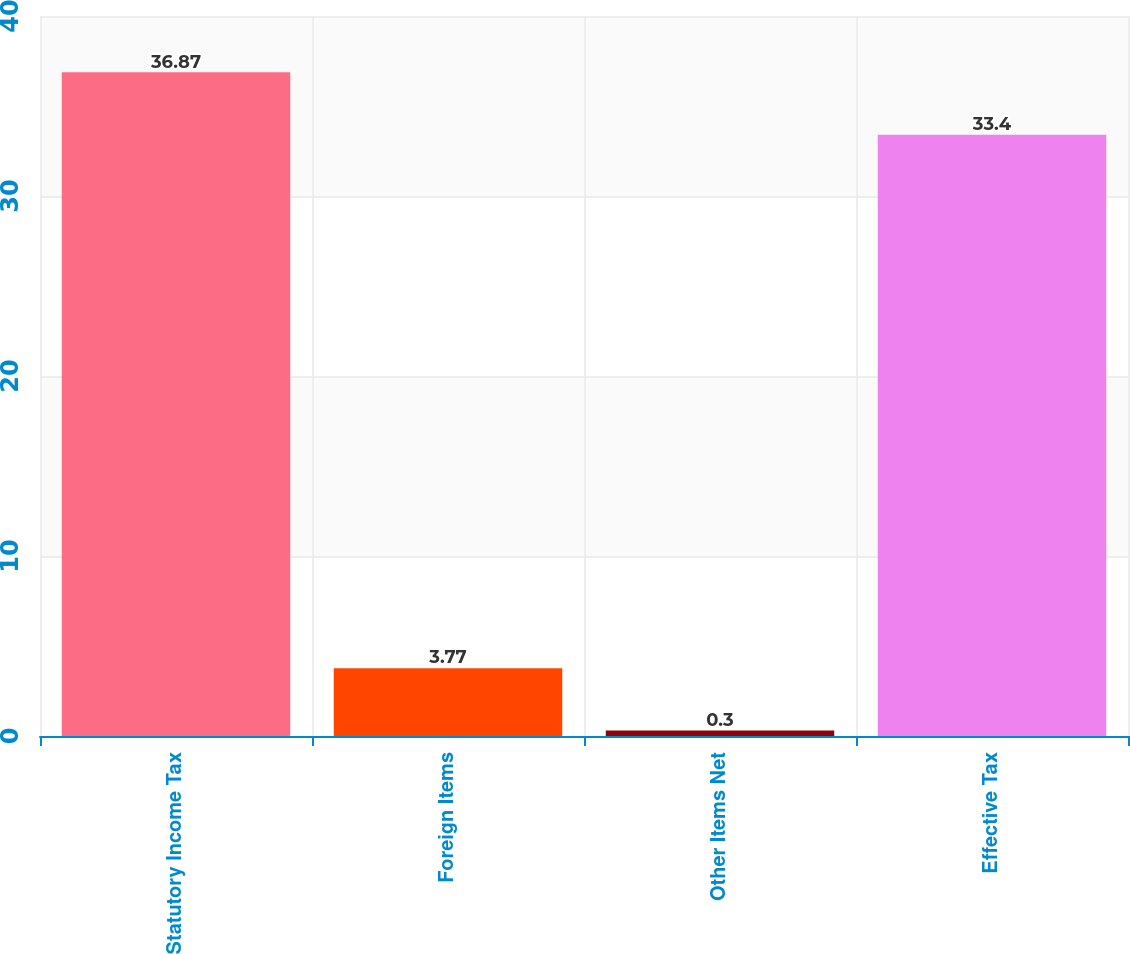<chart> <loc_0><loc_0><loc_500><loc_500><bar_chart><fcel>Statutory Income Tax<fcel>Foreign Items<fcel>Other Items Net<fcel>Effective Tax<nl><fcel>36.87<fcel>3.77<fcel>0.3<fcel>33.4<nl></chart> 